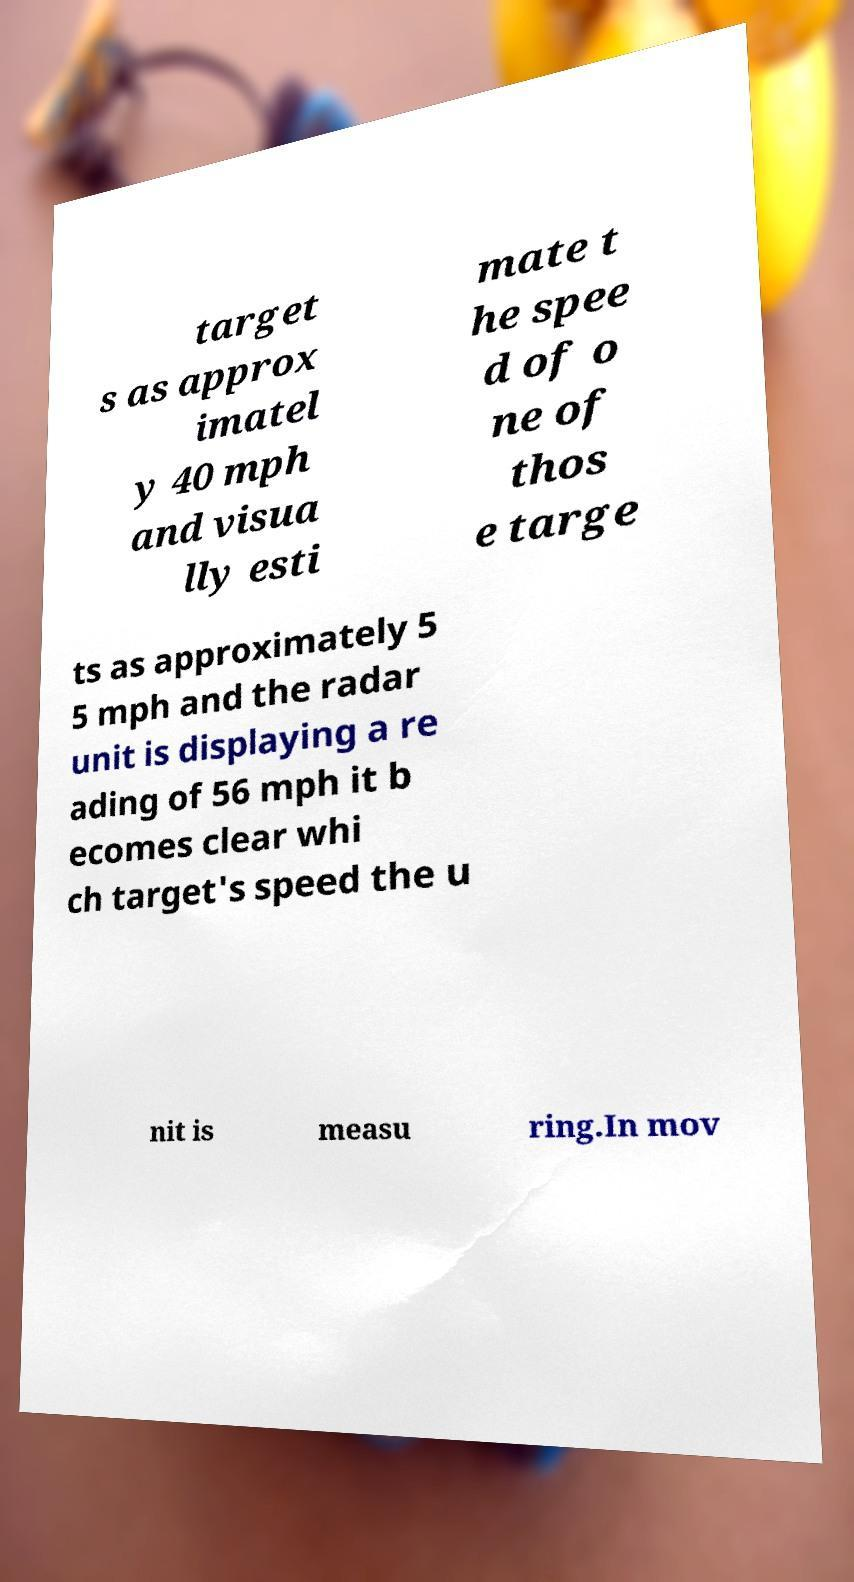Please read and relay the text visible in this image. What does it say? target s as approx imatel y 40 mph and visua lly esti mate t he spee d of o ne of thos e targe ts as approximately 5 5 mph and the radar unit is displaying a re ading of 56 mph it b ecomes clear whi ch target's speed the u nit is measu ring.In mov 